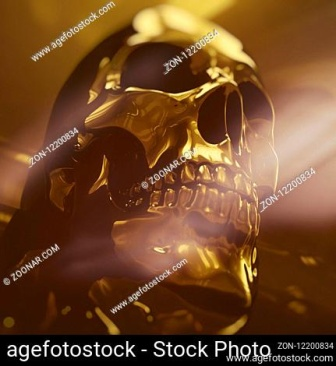What artistic or cultural significance could a golden skull symbolize? A golden skull can be rich with artistic and cultural symbolism. In many cultures, skulls represent mortality, death, and the impermanence of life. The addition of gold, a symbol of wealth, eternity, and purity, creates a powerful juxtaposition. It could be interpreted as a statement on the fleeting nature of material wealth versus the permanence of death, or perhaps as a celebration of life’s enduring spirit. The use of a golden skull in art may also evoke thoughts on the glorification of death or the veneration of ancestors. 